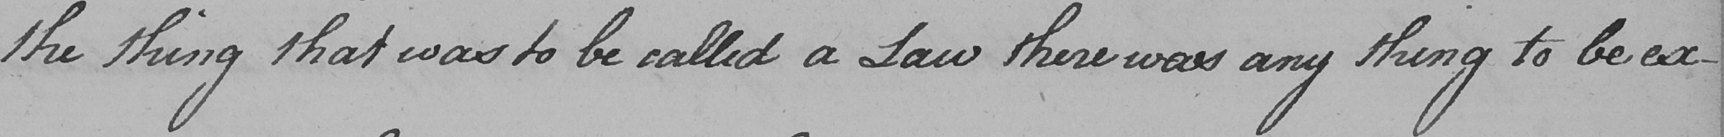What does this handwritten line say? the thing that was to be called a Law there was any thing to be ex- 